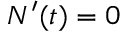Convert formula to latex. <formula><loc_0><loc_0><loc_500><loc_500>N ^ { \prime } ( t ) = 0</formula> 